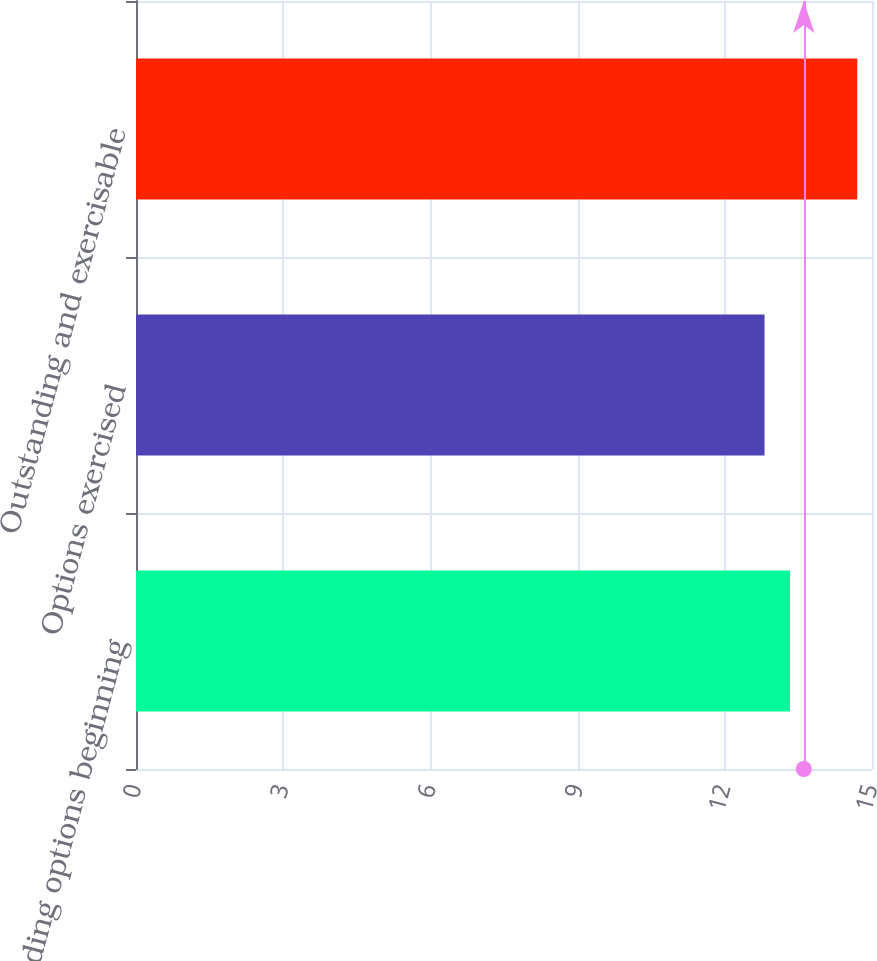<chart> <loc_0><loc_0><loc_500><loc_500><bar_chart><fcel>Outstanding options beginning<fcel>Options exercised<fcel>Outstanding and exercisable<nl><fcel>13.33<fcel>12.81<fcel>14.7<nl></chart> 